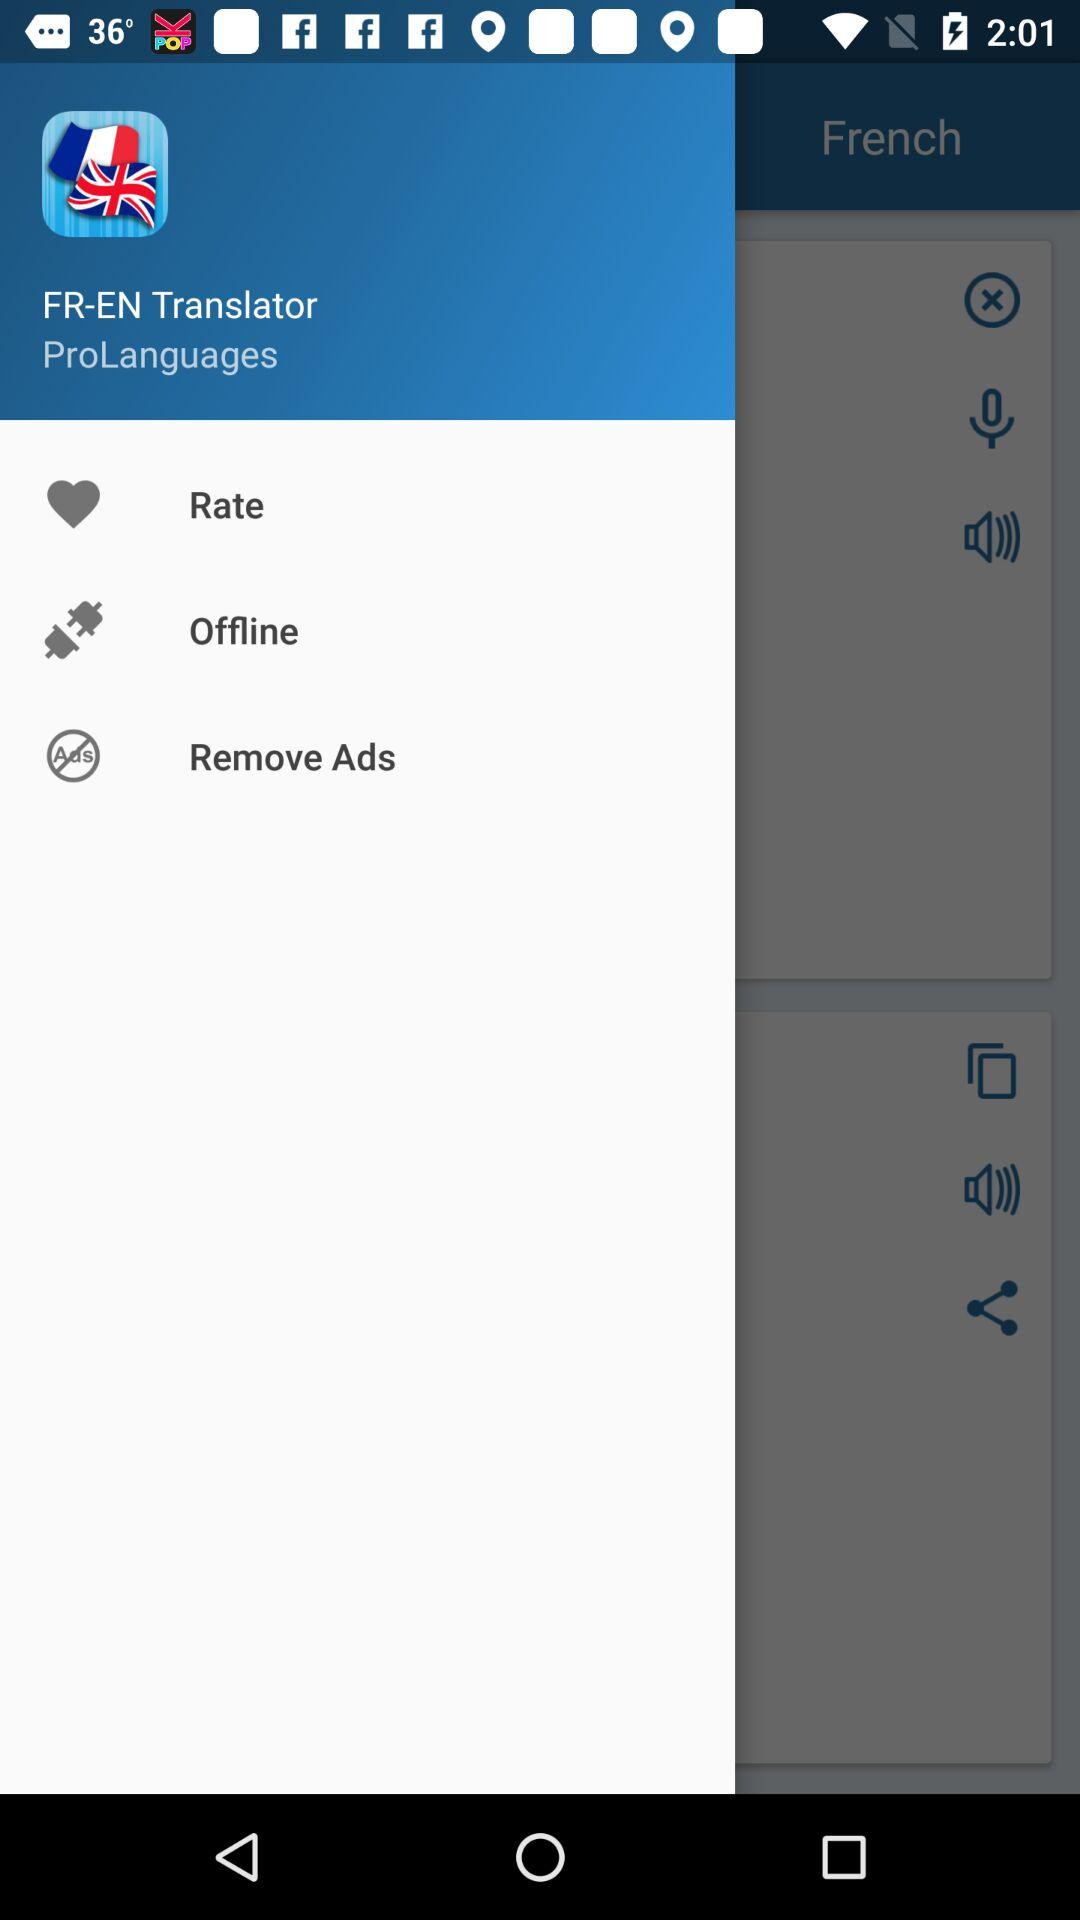What is the application name? The application name is "FR-EN Translator". 